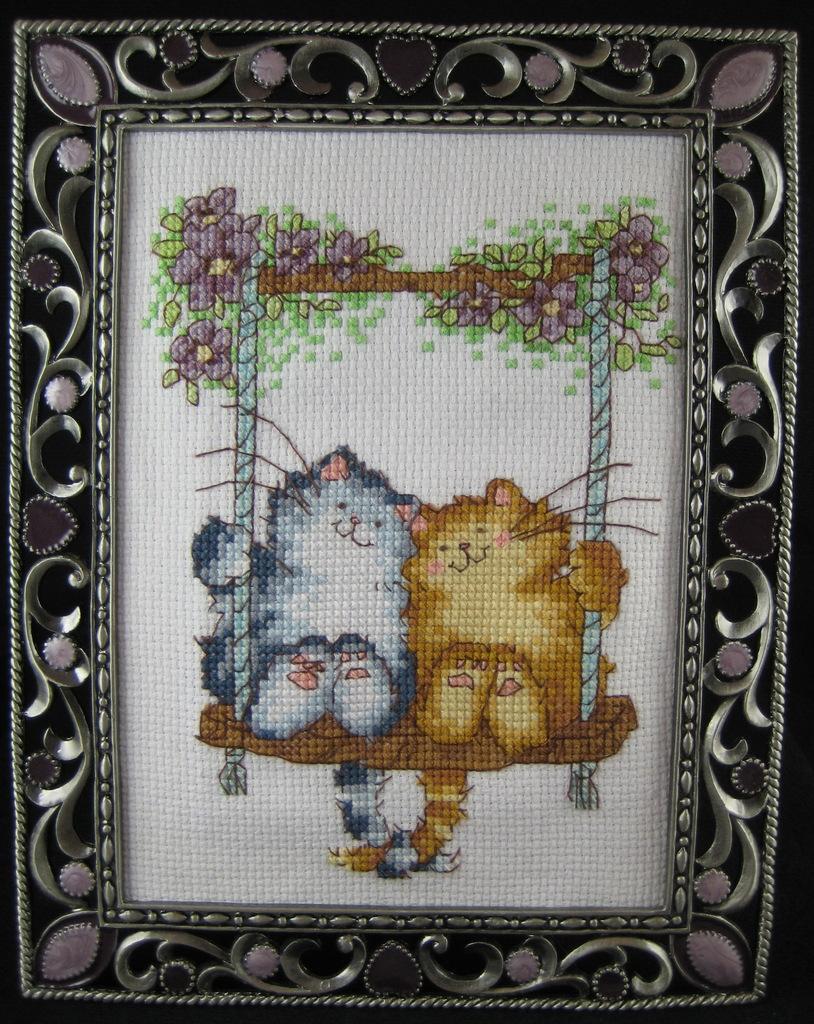How would you summarize this image in a sentence or two? In this image, we can see a photo frame. In the photo frame, we can see a painting, two animals which are on the cradle, some plants with flowers. In the background, we can see white color. 